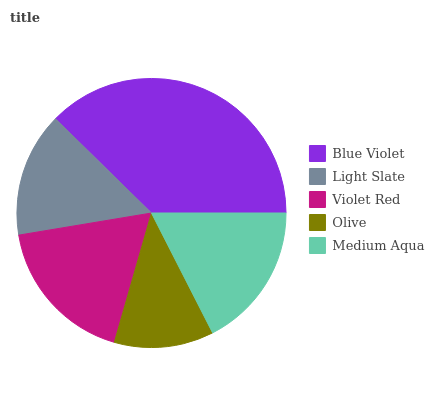Is Olive the minimum?
Answer yes or no. Yes. Is Blue Violet the maximum?
Answer yes or no. Yes. Is Light Slate the minimum?
Answer yes or no. No. Is Light Slate the maximum?
Answer yes or no. No. Is Blue Violet greater than Light Slate?
Answer yes or no. Yes. Is Light Slate less than Blue Violet?
Answer yes or no. Yes. Is Light Slate greater than Blue Violet?
Answer yes or no. No. Is Blue Violet less than Light Slate?
Answer yes or no. No. Is Medium Aqua the high median?
Answer yes or no. Yes. Is Medium Aqua the low median?
Answer yes or no. Yes. Is Violet Red the high median?
Answer yes or no. No. Is Light Slate the low median?
Answer yes or no. No. 